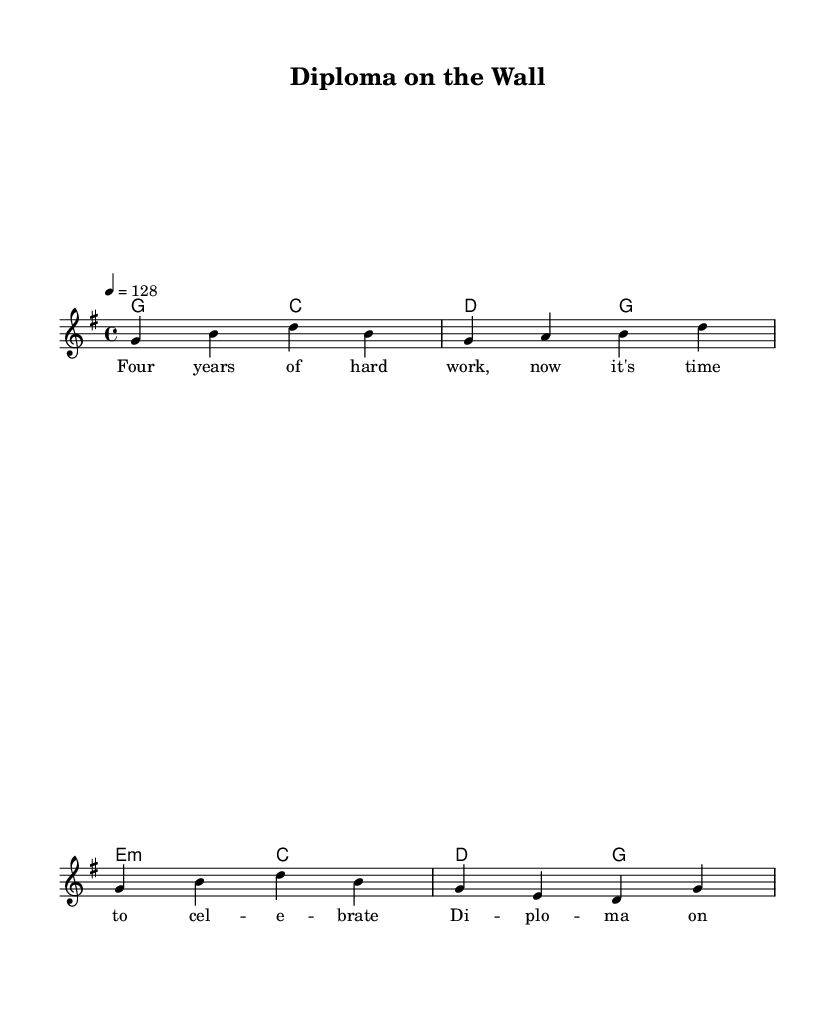What is the key signature of this music? The key signature is G major, which has one sharp (F#). This can be identified by looking at the key signature indicated at the beginning of the music score.
Answer: G major What is the time signature of this music? The time signature is 4/4, which means there are four beats in each measure and a quarter note receives one beat. This is typically represented at the beginning of the score next to the key signature.
Answer: 4/4 What is the tempo marking of this piece? The tempo marking is 4 = 128, indicating that there are 128 beats per minute. This is specified at the beginning of the score in the tempo section.
Answer: 128 How many measures are in the verse? The verse consists of four measures, which can be counted by looking at the notation and counting the vertical bar lines that indicate the end of each measure.
Answer: 4 What are the starting notes of the melody? The starting notes of the melody are G, B, and D, as indicated by the first note in the melody line. This can be observed at the beginning of the melody section of the score.
Answer: G, B, D What is the main theme of the lyrics? The main theme of the lyrics celebrates graduation and academic achievements, as illustrated by the phrases referencing hard work and the diploma. This can be understood by reading through the lyrics provided in the score.
Answer: Graduation 